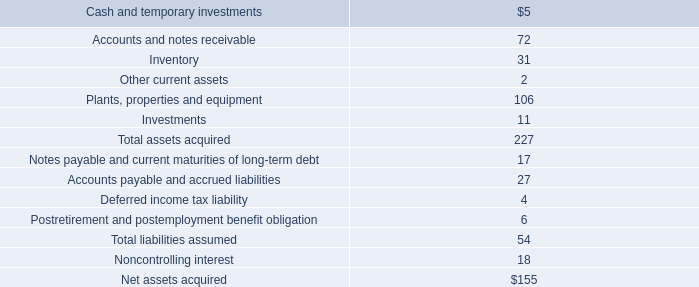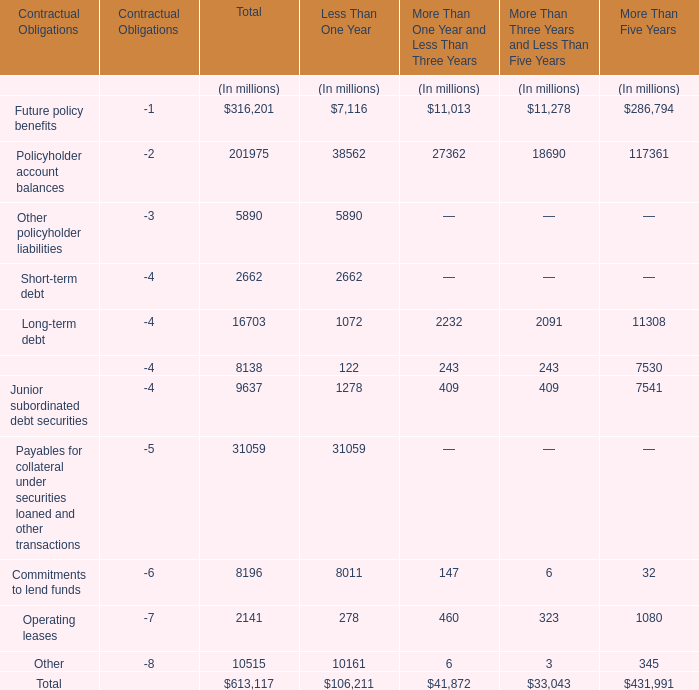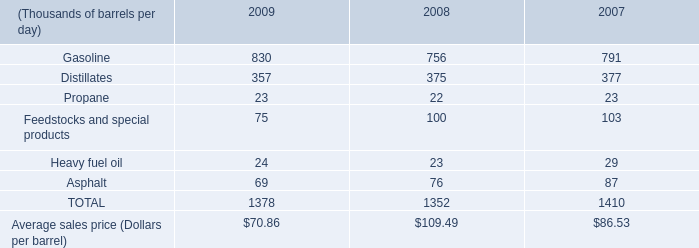What is the sum of the Policyholder account balances in what sections is Future policy benefits positive? (in million) 
Computations: ((((201975 + 38562) + 27362) + 18690) + 117361)
Answer: 403950.0. 